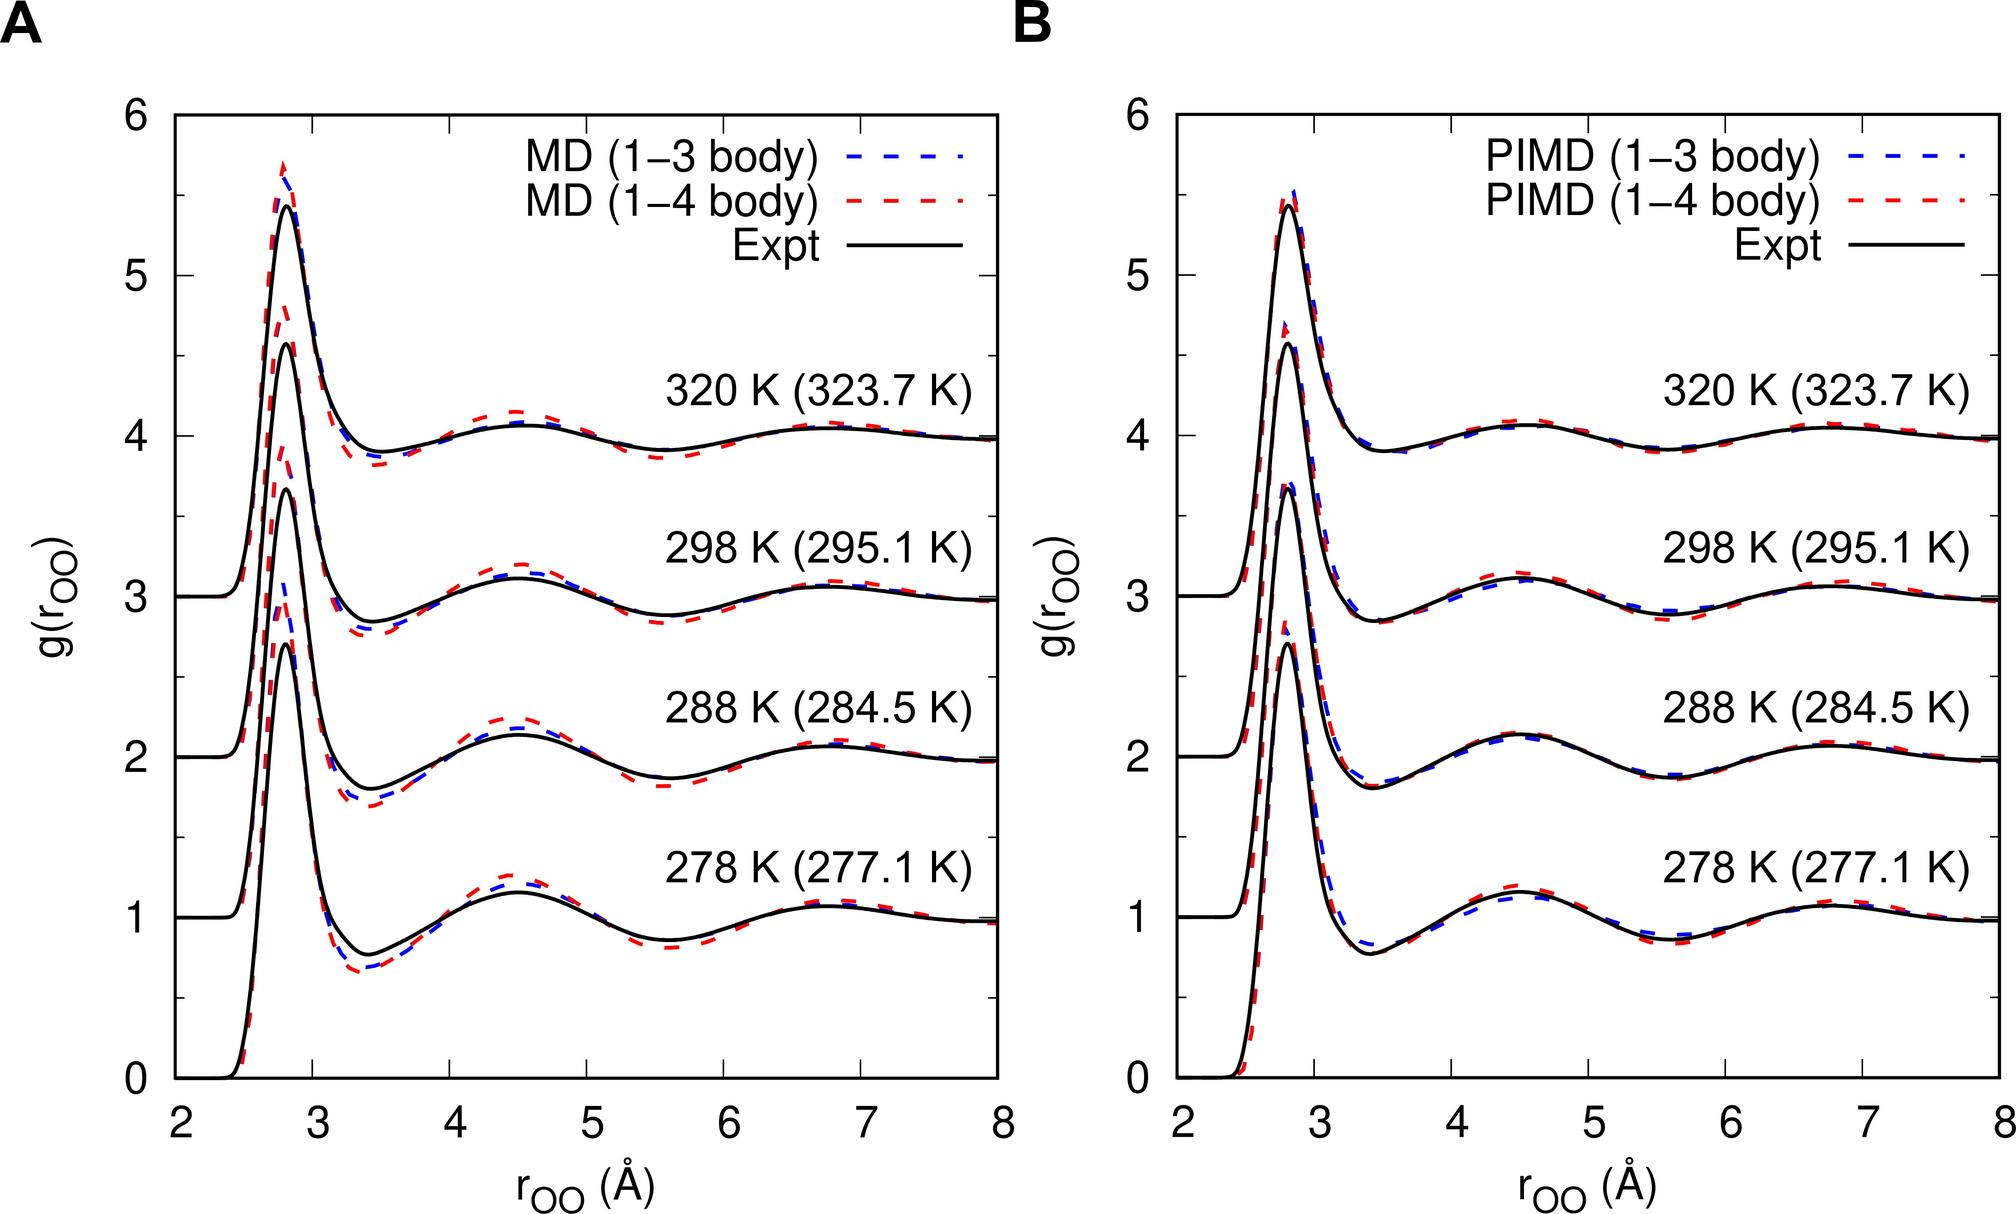Can you explain the relevance of the radial distribution function, g(r), shown in the charts? The radial distribution function, g(r), plotted in these charts, is a key measure in physical chemistry and material science that describes how particle density varies as a function of distance from a reference particle. It helps in understanding the structural arrangement of atoms or molecules in various states and temperatures, providing insights into the molecular dynamics and thermodynamic properties of the material. Its accuracy in predictions can significantly affect the interpretations in theoretical and application-based research. 